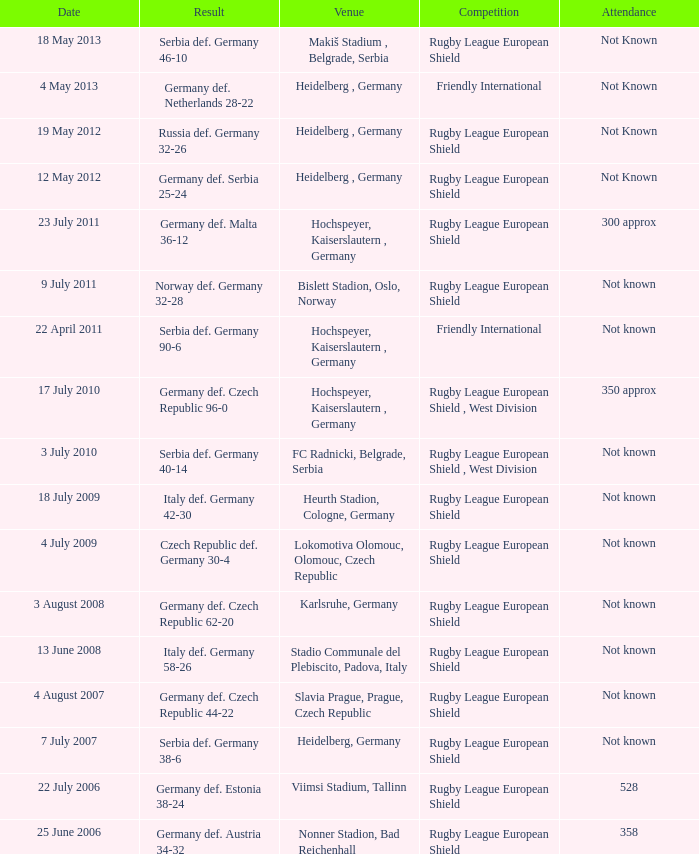For the game with 528 attendance, what was the result? Germany def. Estonia 38-24. 